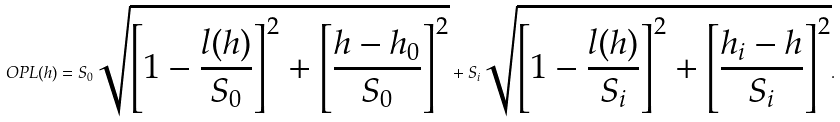Convert formula to latex. <formula><loc_0><loc_0><loc_500><loc_500>O P L ( h ) = S _ { 0 } \sqrt { \left [ 1 - \frac { l ( h ) } { S _ { 0 } } \right ] ^ { 2 } + \left [ \frac { h - h _ { 0 } } { S _ { 0 } } \right ] ^ { 2 } } + S _ { i } \sqrt { \left [ 1 - \frac { l ( h ) } { S _ { i } } \right ] ^ { 2 } + \left [ \frac { h _ { i } - h } { S _ { i } } \right ] ^ { 2 } } .</formula> 